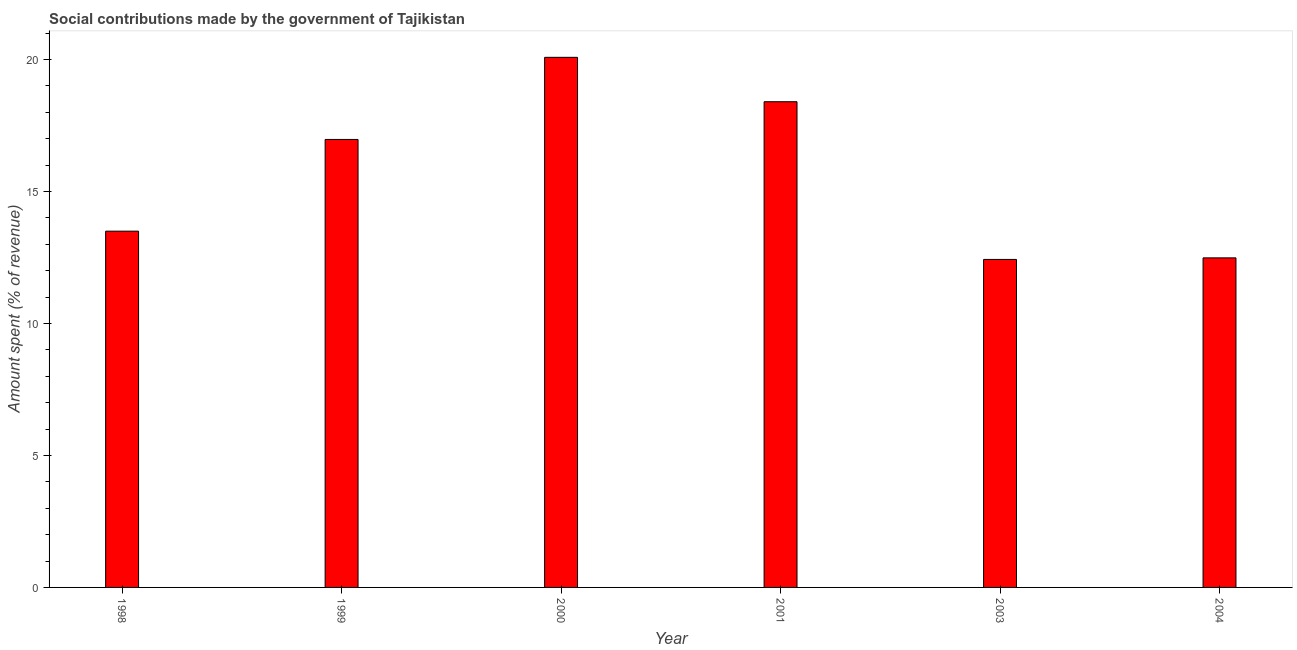Does the graph contain any zero values?
Keep it short and to the point. No. What is the title of the graph?
Offer a terse response. Social contributions made by the government of Tajikistan. What is the label or title of the Y-axis?
Your answer should be compact. Amount spent (% of revenue). What is the amount spent in making social contributions in 2000?
Ensure brevity in your answer.  20.08. Across all years, what is the maximum amount spent in making social contributions?
Your answer should be compact. 20.08. Across all years, what is the minimum amount spent in making social contributions?
Your response must be concise. 12.42. In which year was the amount spent in making social contributions maximum?
Provide a short and direct response. 2000. In which year was the amount spent in making social contributions minimum?
Give a very brief answer. 2003. What is the sum of the amount spent in making social contributions?
Your answer should be very brief. 93.84. What is the difference between the amount spent in making social contributions in 1998 and 2004?
Your response must be concise. 1.01. What is the average amount spent in making social contributions per year?
Your response must be concise. 15.64. What is the median amount spent in making social contributions?
Keep it short and to the point. 15.23. In how many years, is the amount spent in making social contributions greater than 19 %?
Provide a short and direct response. 1. Is the amount spent in making social contributions in 2000 less than that in 2003?
Provide a short and direct response. No. Is the difference between the amount spent in making social contributions in 1999 and 2000 greater than the difference between any two years?
Provide a succinct answer. No. What is the difference between the highest and the second highest amount spent in making social contributions?
Give a very brief answer. 1.68. What is the difference between the highest and the lowest amount spent in making social contributions?
Make the answer very short. 7.65. How many bars are there?
Make the answer very short. 6. Are all the bars in the graph horizontal?
Keep it short and to the point. No. How many years are there in the graph?
Your answer should be very brief. 6. What is the difference between two consecutive major ticks on the Y-axis?
Give a very brief answer. 5. What is the Amount spent (% of revenue) in 1998?
Offer a terse response. 13.49. What is the Amount spent (% of revenue) in 1999?
Provide a succinct answer. 16.97. What is the Amount spent (% of revenue) of 2000?
Your answer should be compact. 20.08. What is the Amount spent (% of revenue) of 2001?
Provide a short and direct response. 18.4. What is the Amount spent (% of revenue) in 2003?
Your answer should be compact. 12.42. What is the Amount spent (% of revenue) in 2004?
Offer a terse response. 12.48. What is the difference between the Amount spent (% of revenue) in 1998 and 1999?
Offer a terse response. -3.47. What is the difference between the Amount spent (% of revenue) in 1998 and 2000?
Offer a terse response. -6.58. What is the difference between the Amount spent (% of revenue) in 1998 and 2001?
Provide a short and direct response. -4.9. What is the difference between the Amount spent (% of revenue) in 1998 and 2003?
Make the answer very short. 1.07. What is the difference between the Amount spent (% of revenue) in 1998 and 2004?
Make the answer very short. 1.01. What is the difference between the Amount spent (% of revenue) in 1999 and 2000?
Ensure brevity in your answer.  -3.11. What is the difference between the Amount spent (% of revenue) in 1999 and 2001?
Your answer should be very brief. -1.43. What is the difference between the Amount spent (% of revenue) in 1999 and 2003?
Your answer should be compact. 4.54. What is the difference between the Amount spent (% of revenue) in 1999 and 2004?
Your answer should be very brief. 4.49. What is the difference between the Amount spent (% of revenue) in 2000 and 2001?
Your answer should be compact. 1.68. What is the difference between the Amount spent (% of revenue) in 2000 and 2003?
Offer a very short reply. 7.65. What is the difference between the Amount spent (% of revenue) in 2000 and 2004?
Your response must be concise. 7.6. What is the difference between the Amount spent (% of revenue) in 2001 and 2003?
Your answer should be compact. 5.97. What is the difference between the Amount spent (% of revenue) in 2001 and 2004?
Keep it short and to the point. 5.91. What is the difference between the Amount spent (% of revenue) in 2003 and 2004?
Your answer should be very brief. -0.06. What is the ratio of the Amount spent (% of revenue) in 1998 to that in 1999?
Provide a succinct answer. 0.8. What is the ratio of the Amount spent (% of revenue) in 1998 to that in 2000?
Provide a succinct answer. 0.67. What is the ratio of the Amount spent (% of revenue) in 1998 to that in 2001?
Your answer should be very brief. 0.73. What is the ratio of the Amount spent (% of revenue) in 1998 to that in 2003?
Provide a short and direct response. 1.09. What is the ratio of the Amount spent (% of revenue) in 1998 to that in 2004?
Give a very brief answer. 1.08. What is the ratio of the Amount spent (% of revenue) in 1999 to that in 2000?
Your answer should be compact. 0.84. What is the ratio of the Amount spent (% of revenue) in 1999 to that in 2001?
Give a very brief answer. 0.92. What is the ratio of the Amount spent (% of revenue) in 1999 to that in 2003?
Offer a very short reply. 1.37. What is the ratio of the Amount spent (% of revenue) in 1999 to that in 2004?
Your answer should be compact. 1.36. What is the ratio of the Amount spent (% of revenue) in 2000 to that in 2001?
Offer a terse response. 1.09. What is the ratio of the Amount spent (% of revenue) in 2000 to that in 2003?
Ensure brevity in your answer.  1.62. What is the ratio of the Amount spent (% of revenue) in 2000 to that in 2004?
Your answer should be compact. 1.61. What is the ratio of the Amount spent (% of revenue) in 2001 to that in 2003?
Keep it short and to the point. 1.48. What is the ratio of the Amount spent (% of revenue) in 2001 to that in 2004?
Provide a short and direct response. 1.47. 